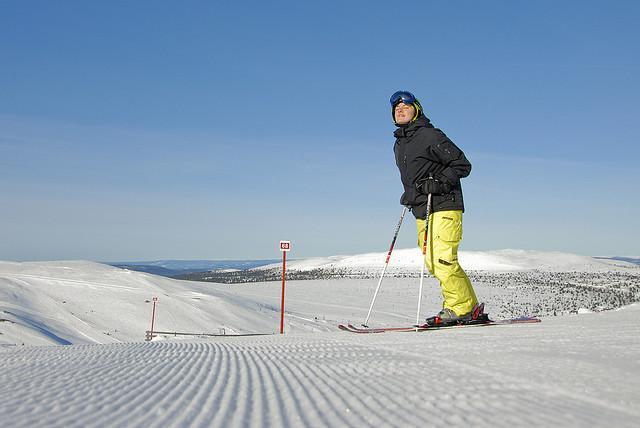How many black horse ?
Give a very brief answer. 0. 